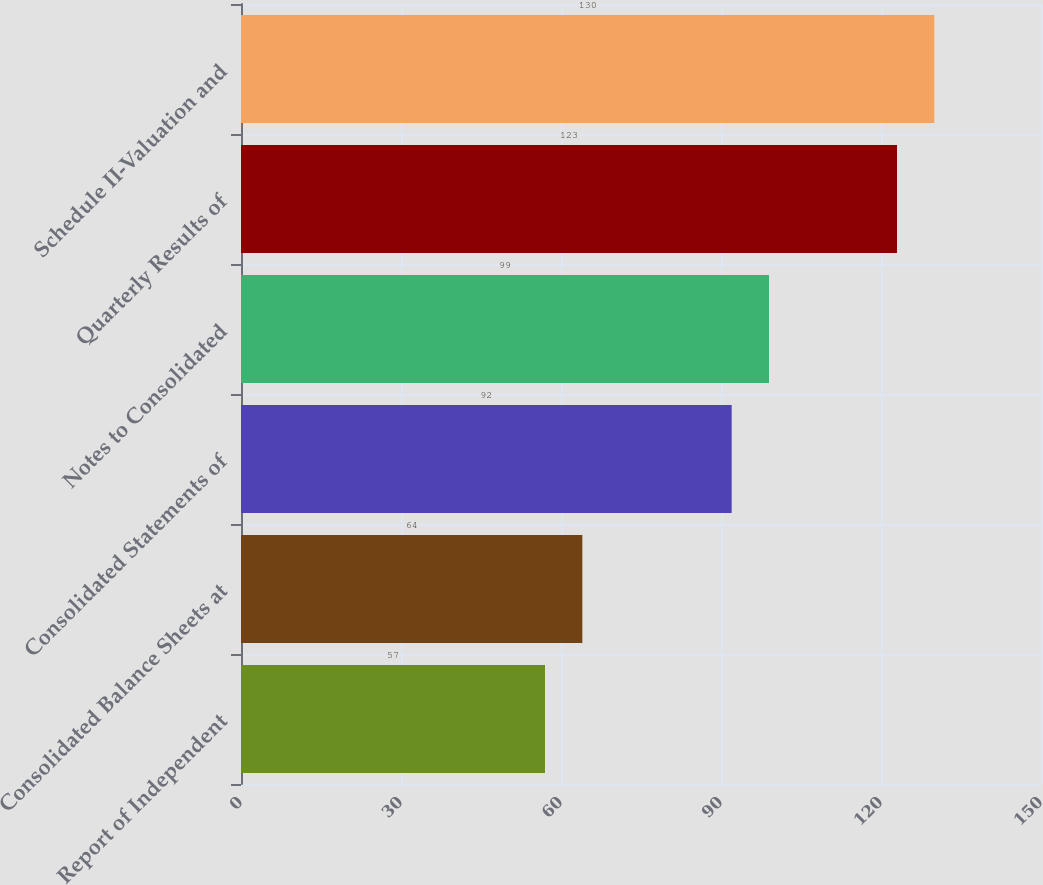Convert chart. <chart><loc_0><loc_0><loc_500><loc_500><bar_chart><fcel>Report of Independent<fcel>Consolidated Balance Sheets at<fcel>Consolidated Statements of<fcel>Notes to Consolidated<fcel>Quarterly Results of<fcel>Schedule II-Valuation and<nl><fcel>57<fcel>64<fcel>92<fcel>99<fcel>123<fcel>130<nl></chart> 